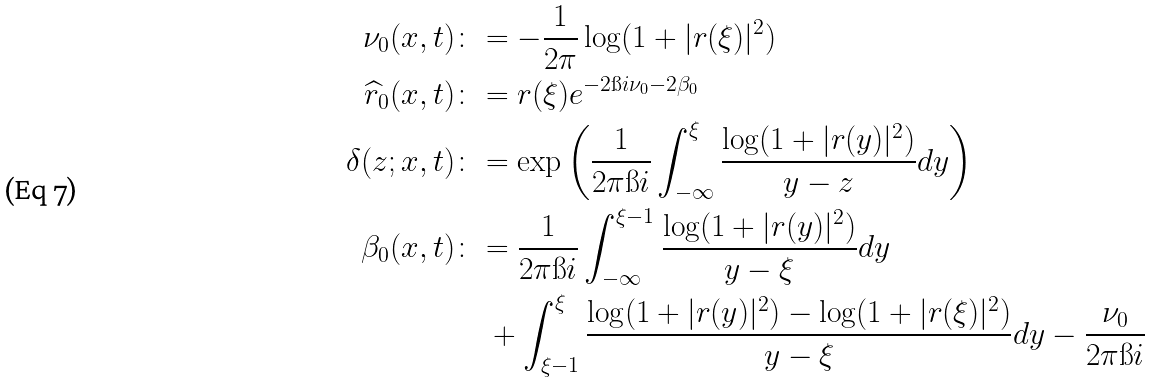Convert formula to latex. <formula><loc_0><loc_0><loc_500><loc_500>\nu _ { 0 } ( x , t ) & \colon = - \frac { 1 } { 2 \pi } \log ( 1 + | r ( \xi ) | ^ { 2 } ) \\ \widehat { r } _ { 0 } ( x , t ) & \colon = r ( \xi ) e ^ { - 2 \i i \nu _ { 0 } - 2 \beta _ { 0 } } \\ \delta ( z ; x , t ) & \colon = \exp \left ( \frac { 1 } { 2 \pi \i i } \int _ { - \infty } ^ { \xi } \frac { \log ( 1 + | r ( y ) | ^ { 2 } ) } { y - z } d y \right ) \\ \beta _ { 0 } ( x , t ) & \colon = \frac { 1 } { 2 \pi \i i } \int _ { - \infty } ^ { \xi - 1 } \frac { \log ( 1 + | r ( y ) | ^ { 2 } ) } { y - \xi } d y \\ & \quad + \int _ { \xi - 1 } ^ { \xi } \frac { \log ( 1 + | r ( y ) | ^ { 2 } ) - \log ( 1 + | r ( \xi ) | ^ { 2 } ) } { y - \xi } d y - \frac { \nu _ { 0 } } { 2 \pi \i i }</formula> 